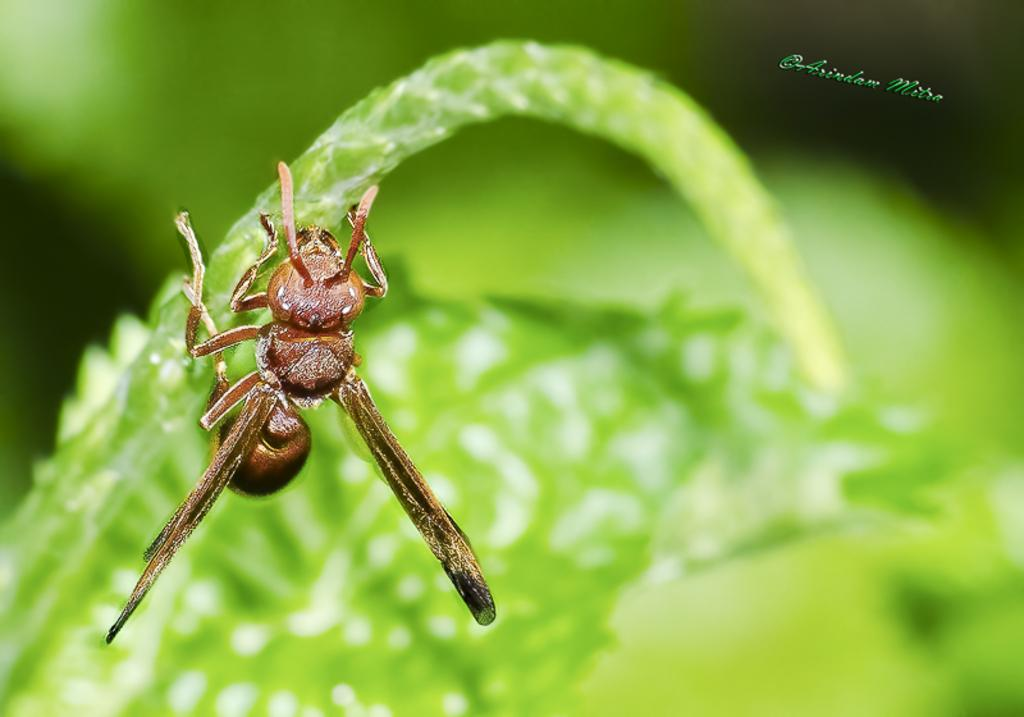What is present on the leaf in the image? There is an insect on the leaf in the image. Can you describe the insect's location on the leaf? The insect is on the leaf in the image. What type of agreement was reached after the aftermath of the print in the image? There is no agreement, aftermath, or print present in the image; it only features an insect on a leaf. 